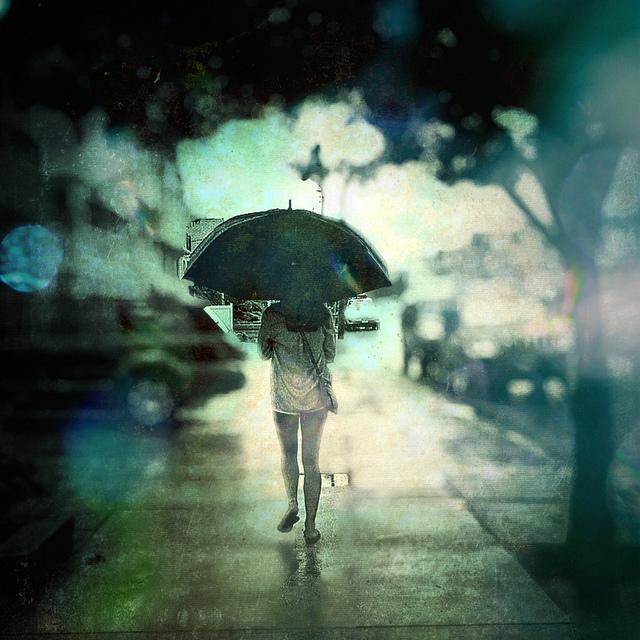How many cars can you see?
Give a very brief answer. 3. 